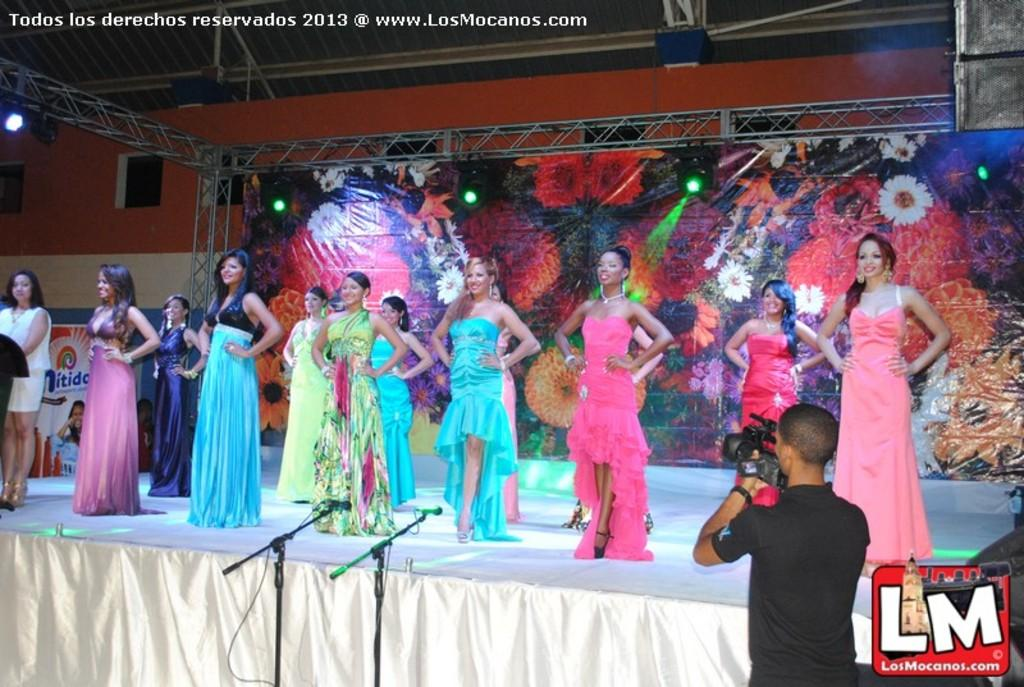What is the woman doing in the image? The woman is standing on the stage. Who is capturing the image? There is a person holding a camera. What type of structure can be seen in the image? There is an iron structure in the image. Can you see any units in the garden in the image? There is no garden or units present in the image; it features a woman standing on a stage and an iron structure. Is there a kite flying in the background of the image? There is no kite present in the image. 